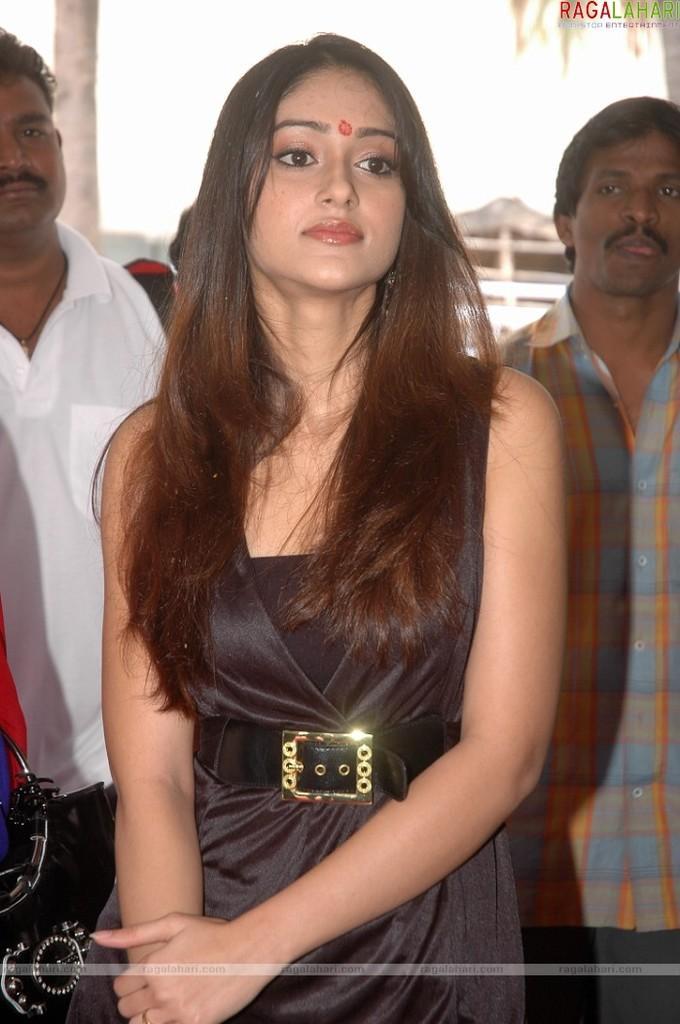Could you give a brief overview of what you see in this image? In this picture I can see a woman standing, there are two persons standing, and there is blur background and there are watermarks on the image. 